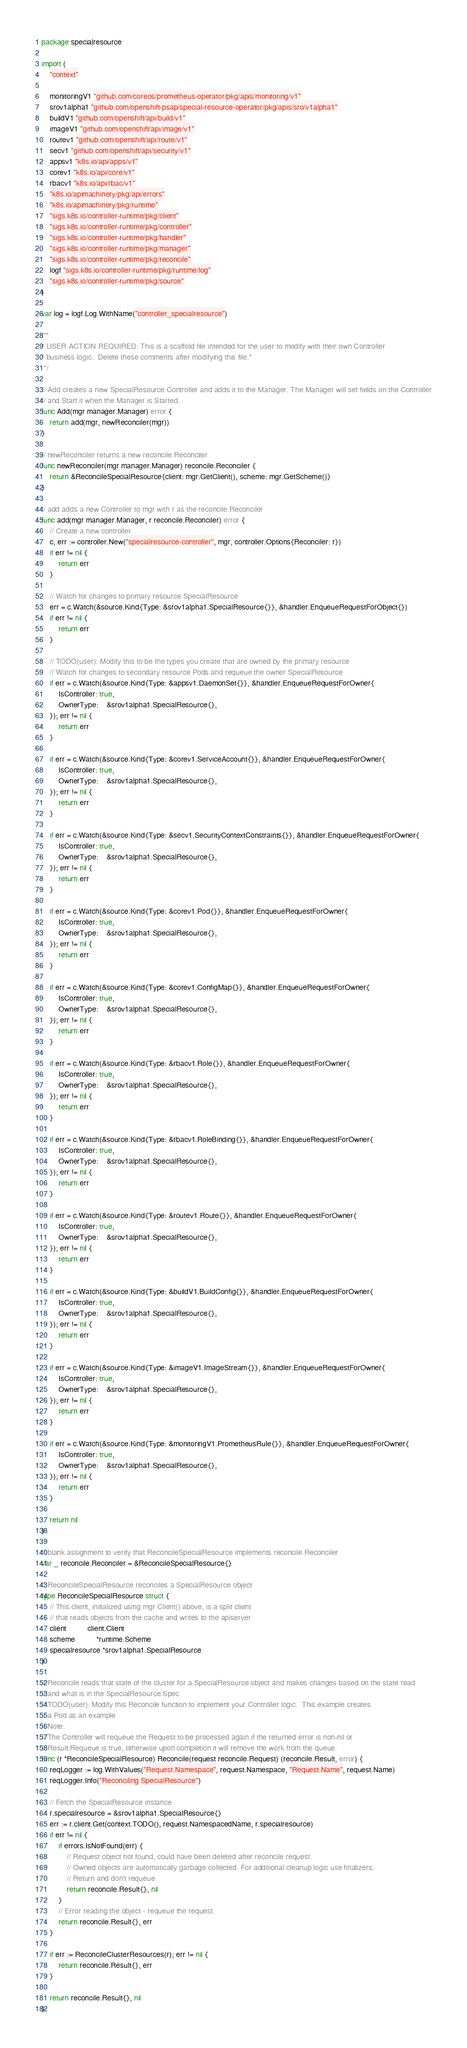<code> <loc_0><loc_0><loc_500><loc_500><_Go_>package specialresource

import (
	"context"

	monitoringV1 "github.com/coreos/prometheus-operator/pkg/apis/monitoring/v1"
	srov1alpha1 "github.com/openshift-psap/special-resource-operator/pkg/apis/sro/v1alpha1"
	buildV1 "github.com/openshift/api/build/v1"
	imageV1 "github.com/openshift/api/image/v1"
	routev1 "github.com/openshift/api/route/v1"
	secv1 "github.com/openshift/api/security/v1"
	appsv1 "k8s.io/api/apps/v1"
	corev1 "k8s.io/api/core/v1"
	rbacv1 "k8s.io/api/rbac/v1"
	"k8s.io/apimachinery/pkg/api/errors"
	"k8s.io/apimachinery/pkg/runtime"
	"sigs.k8s.io/controller-runtime/pkg/client"
	"sigs.k8s.io/controller-runtime/pkg/controller"
	"sigs.k8s.io/controller-runtime/pkg/handler"
	"sigs.k8s.io/controller-runtime/pkg/manager"
	"sigs.k8s.io/controller-runtime/pkg/reconcile"
	logf "sigs.k8s.io/controller-runtime/pkg/runtime/log"
	"sigs.k8s.io/controller-runtime/pkg/source"
)

var log = logf.Log.WithName("controller_specialresource")

/**
* USER ACTION REQUIRED: This is a scaffold file intended for the user to modify with their own Controller
* business logic.  Delete these comments after modifying this file.*
 */

// Add creates a new SpecialResource Controller and adds it to the Manager. The Manager will set fields on the Controller
// and Start it when the Manager is Started.
func Add(mgr manager.Manager) error {
	return add(mgr, newReconciler(mgr))
}

// newReconciler returns a new reconcile.Reconciler
func newReconciler(mgr manager.Manager) reconcile.Reconciler {
	return &ReconcileSpecialResource{client: mgr.GetClient(), scheme: mgr.GetScheme()}
}

// add adds a new Controller to mgr with r as the reconcile.Reconciler
func add(mgr manager.Manager, r reconcile.Reconciler) error {
	// Create a new controller
	c, err := controller.New("specialresource-controller", mgr, controller.Options{Reconciler: r})
	if err != nil {
		return err
	}

	// Watch for changes to primary resource SpecialResource
	err = c.Watch(&source.Kind{Type: &srov1alpha1.SpecialResource{}}, &handler.EnqueueRequestForObject{})
	if err != nil {
		return err
	}

	// TODO(user): Modify this to be the types you create that are owned by the primary resource
	// Watch for changes to secondary resource Pods and requeue the owner SpecialResource
	if err = c.Watch(&source.Kind{Type: &appsv1.DaemonSet{}}, &handler.EnqueueRequestForOwner{
		IsController: true,
		OwnerType:    &srov1alpha1.SpecialResource{},
	}); err != nil {
		return err
	}

	if err = c.Watch(&source.Kind{Type: &corev1.ServiceAccount{}}, &handler.EnqueueRequestForOwner{
		IsController: true,
		OwnerType:    &srov1alpha1.SpecialResource{},
	}); err != nil {
		return err
	}

	if err = c.Watch(&source.Kind{Type: &secv1.SecurityContextConstraints{}}, &handler.EnqueueRequestForOwner{
		IsController: true,
		OwnerType:    &srov1alpha1.SpecialResource{},
	}); err != nil {
		return err
	}

	if err = c.Watch(&source.Kind{Type: &corev1.Pod{}}, &handler.EnqueueRequestForOwner{
		IsController: true,
		OwnerType:    &srov1alpha1.SpecialResource{},
	}); err != nil {
		return err
	}

	if err = c.Watch(&source.Kind{Type: &corev1.ConfigMap{}}, &handler.EnqueueRequestForOwner{
		IsController: true,
		OwnerType:    &srov1alpha1.SpecialResource{},
	}); err != nil {
		return err
	}

	if err = c.Watch(&source.Kind{Type: &rbacv1.Role{}}, &handler.EnqueueRequestForOwner{
		IsController: true,
		OwnerType:    &srov1alpha1.SpecialResource{},
	}); err != nil {
		return err
	}

	if err = c.Watch(&source.Kind{Type: &rbacv1.RoleBinding{}}, &handler.EnqueueRequestForOwner{
		IsController: true,
		OwnerType:    &srov1alpha1.SpecialResource{},
	}); err != nil {
		return err
	}

	if err = c.Watch(&source.Kind{Type: &routev1.Route{}}, &handler.EnqueueRequestForOwner{
		IsController: true,
		OwnerType:    &srov1alpha1.SpecialResource{},
	}); err != nil {
		return err
	}

	if err = c.Watch(&source.Kind{Type: &buildV1.BuildConfig{}}, &handler.EnqueueRequestForOwner{
		IsController: true,
		OwnerType:    &srov1alpha1.SpecialResource{},
	}); err != nil {
		return err
	}

	if err = c.Watch(&source.Kind{Type: &imageV1.ImageStream{}}, &handler.EnqueueRequestForOwner{
		IsController: true,
		OwnerType:    &srov1alpha1.SpecialResource{},
	}); err != nil {
		return err
	}

	if err = c.Watch(&source.Kind{Type: &monitoringV1.PrometheusRule{}}, &handler.EnqueueRequestForOwner{
		IsController: true,
		OwnerType:    &srov1alpha1.SpecialResource{},
	}); err != nil {
		return err
	}

	return nil
}

// blank assignment to verify that ReconcileSpecialResource implements reconcile.Reconciler
var _ reconcile.Reconciler = &ReconcileSpecialResource{}

// ReconcileSpecialResource reconciles a SpecialResource object
type ReconcileSpecialResource struct {
	// This client, initialized using mgr.Client() above, is a split client
	// that reads objects from the cache and writes to the apiserver
	client          client.Client
	scheme          *runtime.Scheme
	specialresource *srov1alpha1.SpecialResource
}

// Reconcile reads that state of the cluster for a SpecialResource object and makes changes based on the state read
// and what is in the SpecialResource.Spec
// TODO(user): Modify this Reconcile function to implement your Controller logic.  This example creates
// a Pod as an example
// Note:
// The Controller will requeue the Request to be processed again if the returned error is non-nil or
// Result.Requeue is true, otherwise upon completion it will remove the work from the queue.
func (r *ReconcileSpecialResource) Reconcile(request reconcile.Request) (reconcile.Result, error) {
	reqLogger := log.WithValues("Request.Namespace", request.Namespace, "Request.Name", request.Name)
	reqLogger.Info("Reconciling SpecialResource")

	// Fetch the SpecialResource instance
	r.specialresource = &srov1alpha1.SpecialResource{}
	err := r.client.Get(context.TODO(), request.NamespacedName, r.specialresource)
	if err != nil {
		if errors.IsNotFound(err) {
			// Request object not found, could have been deleted after reconcile request.
			// Owned objects are automatically garbage collected. For additional cleanup logic use finalizers.
			// Return and don't requeue
			return reconcile.Result{}, nil
		}
		// Error reading the object - requeue the request.
		return reconcile.Result{}, err
	}

	if err := ReconcileClusterResources(r); err != nil {
		return reconcile.Result{}, err
	}

	return reconcile.Result{}, nil
}
</code> 